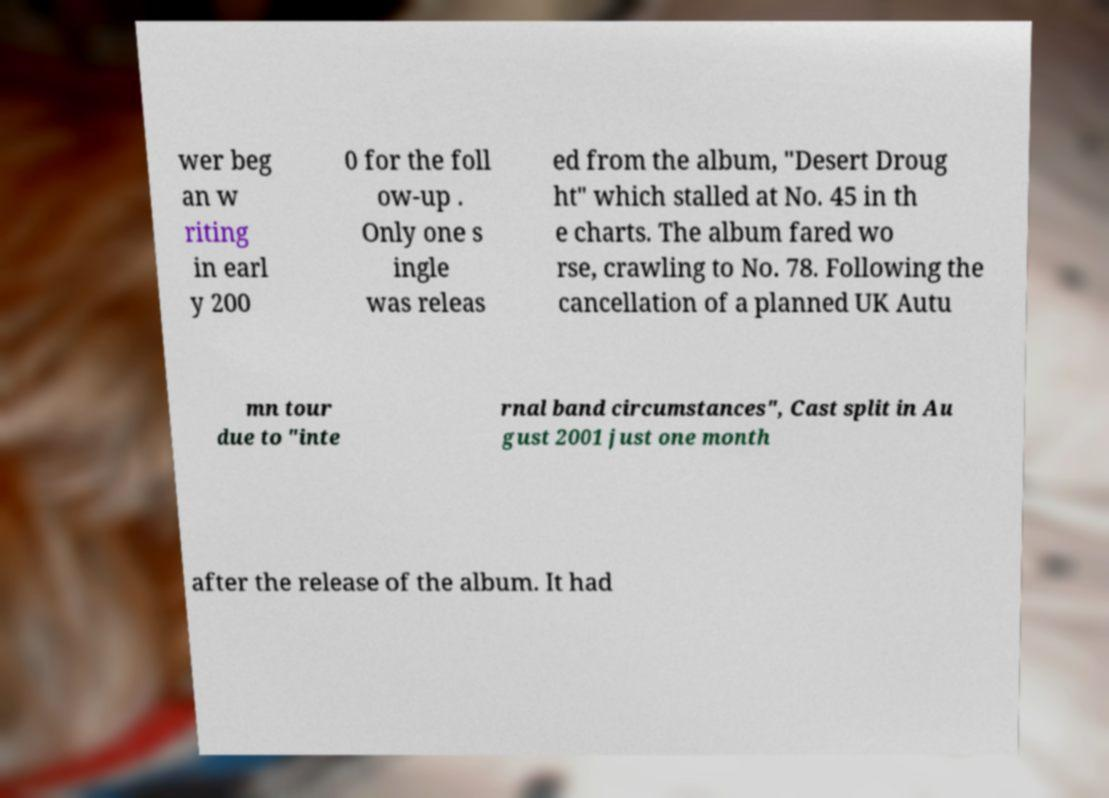Could you assist in decoding the text presented in this image and type it out clearly? wer beg an w riting in earl y 200 0 for the foll ow-up . Only one s ingle was releas ed from the album, "Desert Droug ht" which stalled at No. 45 in th e charts. The album fared wo rse, crawling to No. 78. Following the cancellation of a planned UK Autu mn tour due to "inte rnal band circumstances", Cast split in Au gust 2001 just one month after the release of the album. It had 